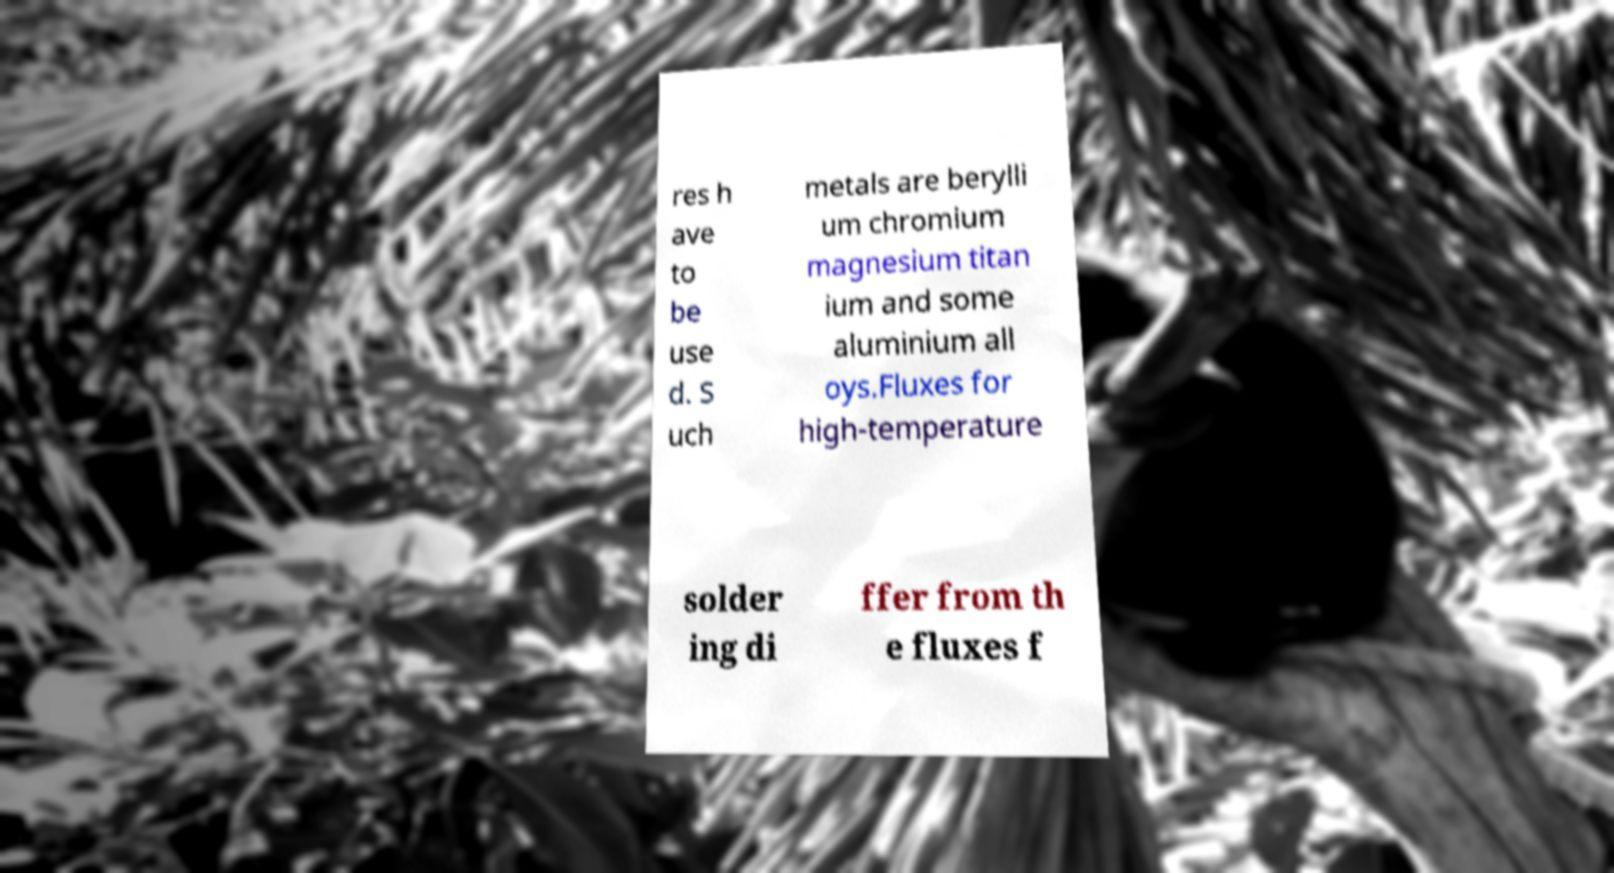For documentation purposes, I need the text within this image transcribed. Could you provide that? res h ave to be use d. S uch metals are berylli um chromium magnesium titan ium and some aluminium all oys.Fluxes for high-temperature solder ing di ffer from th e fluxes f 